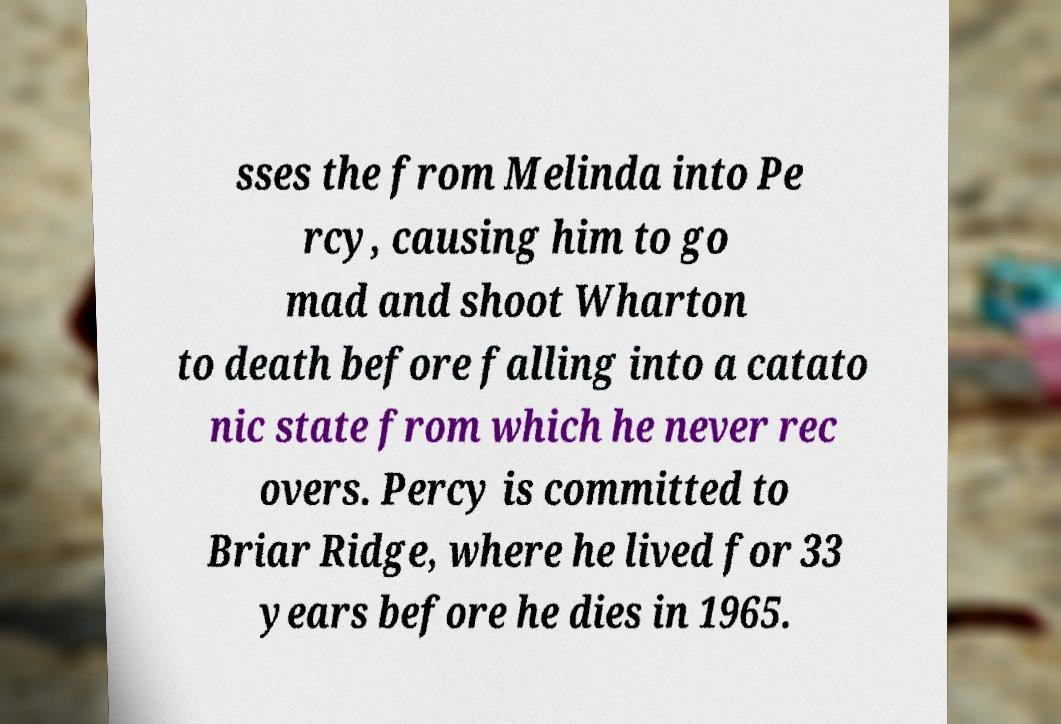I need the written content from this picture converted into text. Can you do that? sses the from Melinda into Pe rcy, causing him to go mad and shoot Wharton to death before falling into a catato nic state from which he never rec overs. Percy is committed to Briar Ridge, where he lived for 33 years before he dies in 1965. 